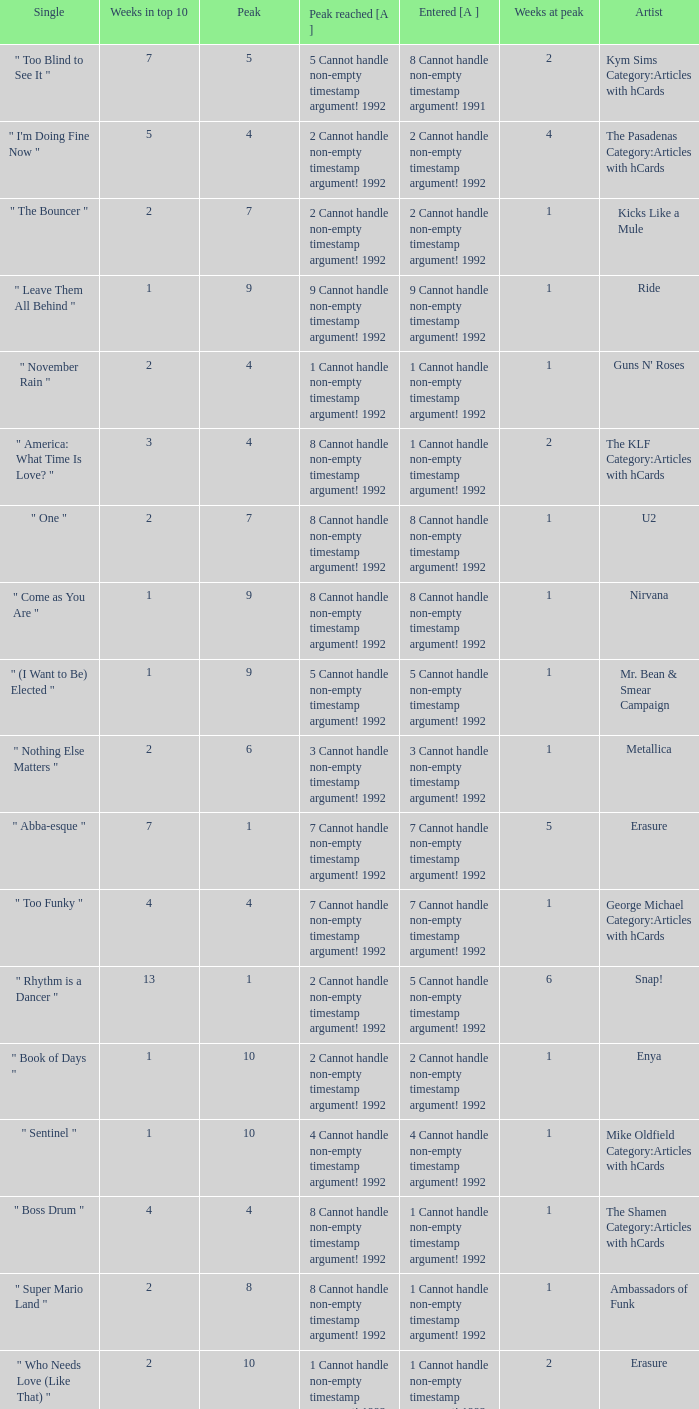What was the peak reached for a single with 4 weeks in the top 10 and entered in 7 cannot handle non-empty timestamp argument! 1992? 7 Cannot handle non-empty timestamp argument! 1992. 